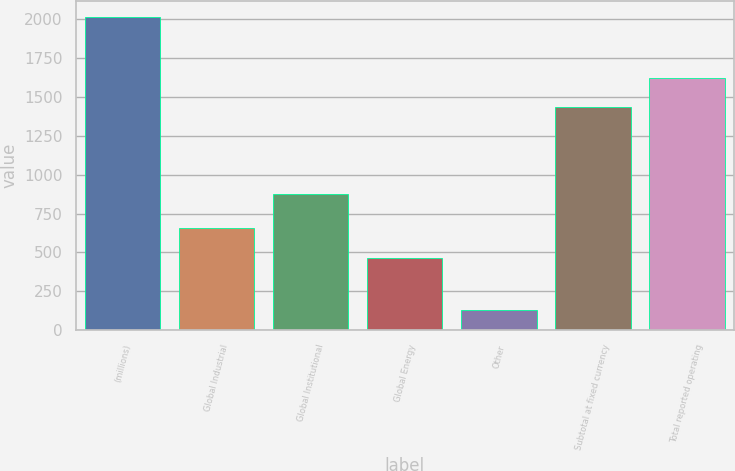Convert chart. <chart><loc_0><loc_0><loc_500><loc_500><bar_chart><fcel>(millions)<fcel>Global Industrial<fcel>Global Institutional<fcel>Global Energy<fcel>Other<fcel>Subtotal at fixed currency<fcel>Total reported operating<nl><fcel>2015<fcel>654.25<fcel>876.6<fcel>465.5<fcel>127.5<fcel>1432.2<fcel>1620.95<nl></chart> 